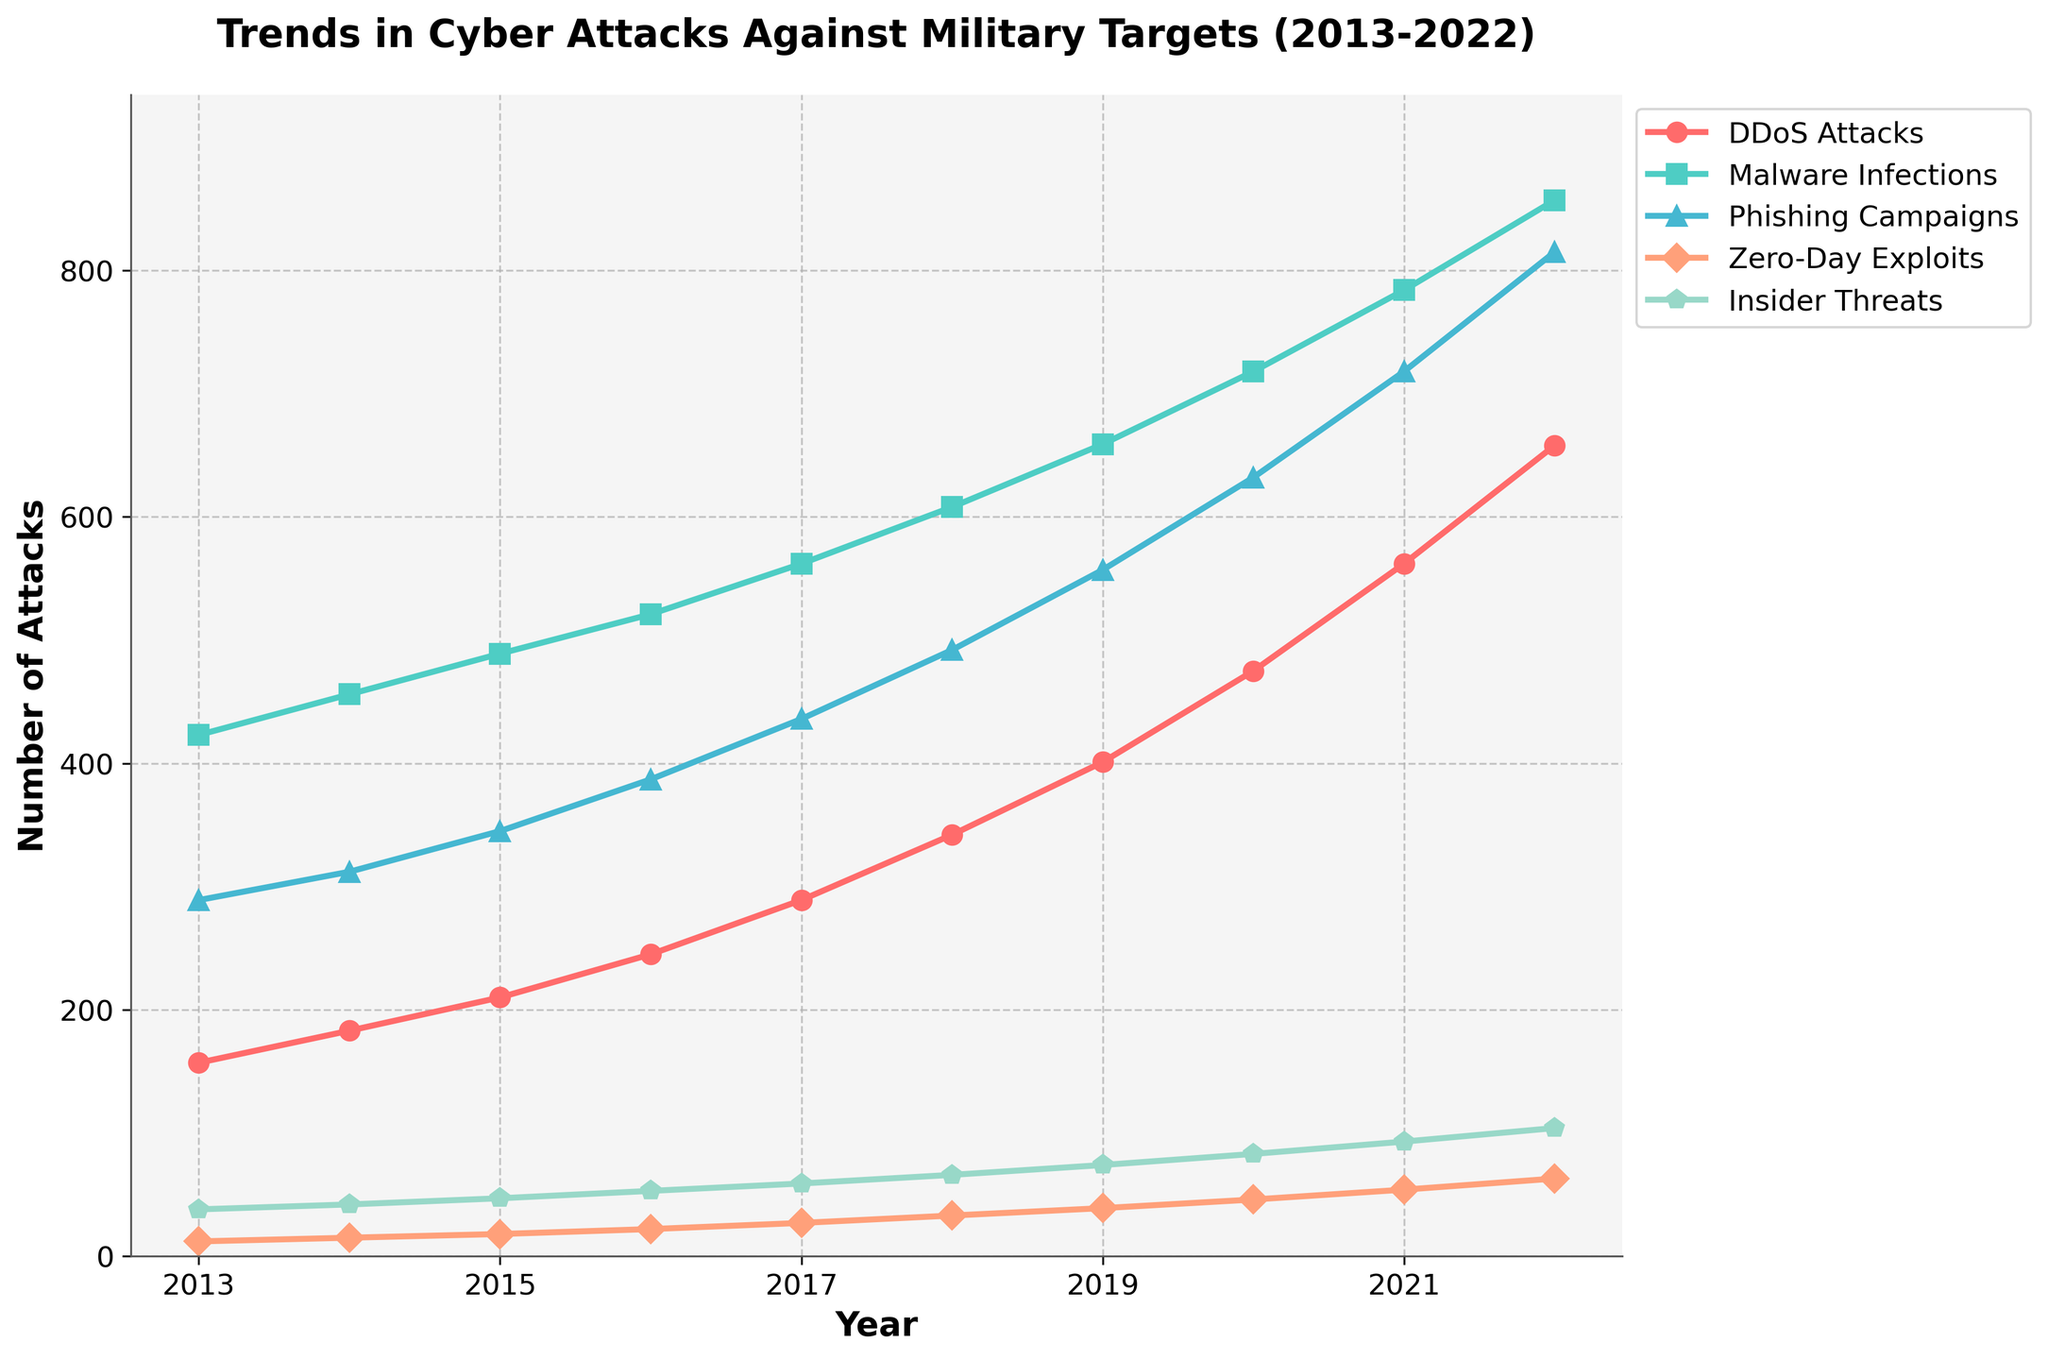How many DDoS attacks occurred in 2015, and how does this compare to the number of DDoS attacks in 2021? The figure shows the number of DDoS attacks for every year. For 2015, it is around 210, and for 2021, it is about 562. To find the difference, subtract 210 from 562.
Answer: There were 210 DDoS attacks in 2015, and this is 352 fewer than the 562 attacks in 2021 Which attack type showed the most substantial increase in numbers from 2013 to 2022? Look at the figure to identify the attack type with the largest change in the y-values from 2013 to 2022. Calculate the difference for each attack type.
Answer: Phishing Campaigns showed the most substantial increase Among the five attack types, which one had the least number of attacks in 2016? Review the figure to identify the lowest point on the y-axis for the year 2016.
Answer: Zero-Day Exploits had the least number of attacks in 2016 What is the total number of DDoS attacks and Malware Infections in the year 2020? Add the number of DDoS attacks and Malware Infections for the year 2020 according to the figure.
Answer: 475 + 718 = 1193 Compare the trends of Malware Infections and Zero-Day Exploits from 2013 to 2022. Which one shows a steeper increase? Evaluate the slope of the lines representing Malware Infections and Zero-Day Exploits by examining how quickly each line rises year over year.
Answer: Malware Infections show a steeper increase How does the number of Insider Threats in 2015 compare to the number of Zero-Day Exploits in 2019? Compare the y-values for Insider Threats in 2015 and Zero-Day Exploits in 2019 marked by distinct colors and markers.
Answer: Insider Threats in 2015 (47) are higher than Zero-Day Exploits in 2019 (39) What is the average number of Phishing Campaigns from 2013 to 2017? Sum the number of Phishing Campaigns for the years 2013 to 2017, then divide by the total number of years (5).
Answer: (289 + 312 + 345 + 387 + 436) / 5 = 353.8 Which two years show the highest and lowest values for Malware Infections, and what are those values? Look at the high and low points on the line representing Malware Infections. Identify the corresponding years and values.
Answer: Highest: 2022 (857), Lowest: 2013 (423) Observing the visual attributes, which attack type is represented by the color green, and how did its numbers change over the decade? Identify the green-colored line representing one of the attack types and track its changes from 2013 to 2022.
Answer: Malware Infections, increased from 423 to 857 What is the percentage increase in Phishing Campaigns from 2013 to 2022? Calculate the difference in the number of Phishing Campaigns between 2022 and 2013, divide by the 2013 value, and multiply by 100 to get the percentage increase.
Answer: ((815 - 289) / 289) * 100 = 182.35% 